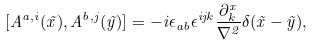<formula> <loc_0><loc_0><loc_500><loc_500>[ A ^ { a , i } ( \vec { x } ) , A ^ { b , j } ( \vec { y } ) ] = - i \epsilon _ { a b } \epsilon ^ { i j k } \frac { \partial ^ { x } _ { k } } { \nabla ^ { 2 } } \delta ( \vec { x } - \vec { y } ) ,</formula> 